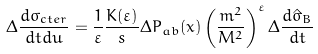Convert formula to latex. <formula><loc_0><loc_0><loc_500><loc_500>\Delta \frac { d \sigma _ { c t e r } } { d t d u } = \frac { 1 } { \varepsilon } \frac { K ( \varepsilon ) } { s } \Delta P _ { a b } ( x ) \left ( \frac { m ^ { 2 } } { M ^ { 2 } } \right ) ^ { \varepsilon } \Delta \frac { d \hat { \sigma } _ { B } } { d t }</formula> 